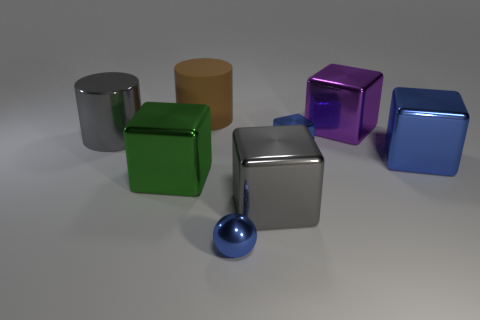What color is the tiny object that is the same shape as the big green shiny object?
Ensure brevity in your answer.  Blue. There is a gray object behind the green cube; what shape is it?
Provide a succinct answer. Cylinder. There is a gray shiny cylinder; are there any gray cubes on the right side of it?
Ensure brevity in your answer.  Yes. There is a tiny ball that is the same material as the purple block; what is its color?
Offer a very short reply. Blue. Do the tiny thing behind the big blue metallic thing and the cube that is to the left of the large matte object have the same color?
Ensure brevity in your answer.  No. How many balls are large matte objects or large metal things?
Ensure brevity in your answer.  0. Is the number of big green cubes right of the small metallic cube the same as the number of big red blocks?
Make the answer very short. Yes. The cylinder behind the large gray object on the left side of the large gray thing right of the small blue sphere is made of what material?
Your answer should be compact. Rubber. How many objects are either big metal things on the right side of the big brown rubber object or gray metal objects?
Offer a terse response. 4. How many objects are metal things or big metallic things that are on the left side of the brown cylinder?
Provide a short and direct response. 7. 